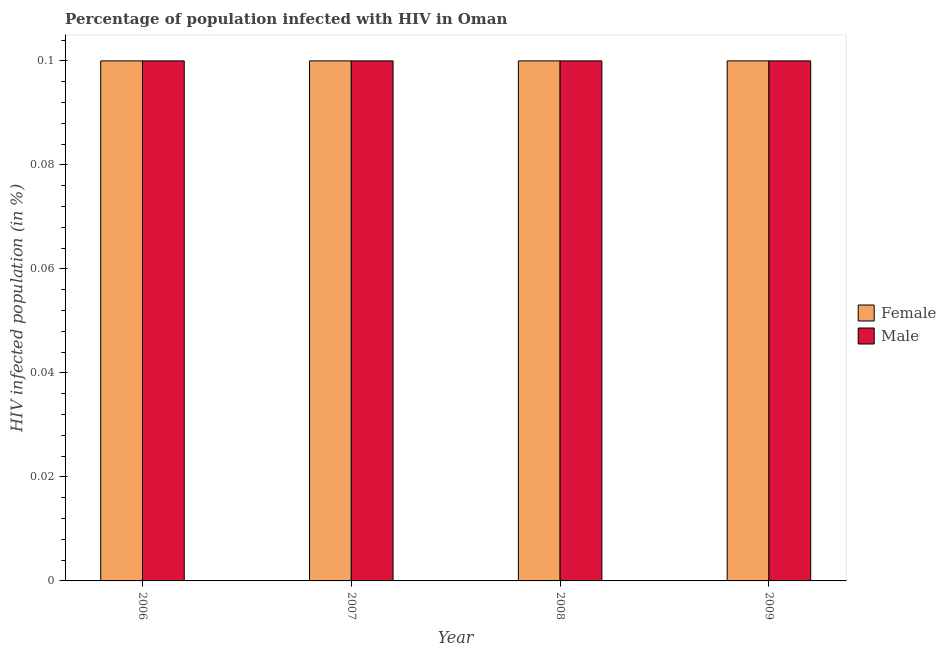How many different coloured bars are there?
Make the answer very short. 2. How many groups of bars are there?
Keep it short and to the point. 4. Are the number of bars on each tick of the X-axis equal?
Give a very brief answer. Yes. How many bars are there on the 1st tick from the right?
Your response must be concise. 2. What is the label of the 3rd group of bars from the left?
Your answer should be very brief. 2008. Across all years, what is the maximum percentage of females who are infected with hiv?
Provide a succinct answer. 0.1. Across all years, what is the minimum percentage of females who are infected with hiv?
Provide a succinct answer. 0.1. In which year was the percentage of females who are infected with hiv maximum?
Your answer should be very brief. 2006. In which year was the percentage of females who are infected with hiv minimum?
Keep it short and to the point. 2006. In how many years, is the percentage of males who are infected with hiv greater than 0.088 %?
Your response must be concise. 4. What is the ratio of the percentage of females who are infected with hiv in 2006 to that in 2007?
Give a very brief answer. 1. What is the difference between the highest and the second highest percentage of males who are infected with hiv?
Provide a short and direct response. 0. In how many years, is the percentage of males who are infected with hiv greater than the average percentage of males who are infected with hiv taken over all years?
Provide a short and direct response. 0. What does the 2nd bar from the right in 2008 represents?
Ensure brevity in your answer.  Female. Are all the bars in the graph horizontal?
Keep it short and to the point. No. What is the difference between two consecutive major ticks on the Y-axis?
Your answer should be very brief. 0.02. Does the graph contain any zero values?
Provide a short and direct response. No. How many legend labels are there?
Make the answer very short. 2. How are the legend labels stacked?
Offer a terse response. Vertical. What is the title of the graph?
Offer a very short reply. Percentage of population infected with HIV in Oman. Does "Largest city" appear as one of the legend labels in the graph?
Keep it short and to the point. No. What is the label or title of the Y-axis?
Make the answer very short. HIV infected population (in %). What is the HIV infected population (in %) in Female in 2006?
Your response must be concise. 0.1. What is the HIV infected population (in %) in Female in 2008?
Ensure brevity in your answer.  0.1. Across all years, what is the maximum HIV infected population (in %) in Male?
Your answer should be compact. 0.1. Across all years, what is the minimum HIV infected population (in %) of Female?
Provide a succinct answer. 0.1. What is the total HIV infected population (in %) in Male in the graph?
Your response must be concise. 0.4. What is the difference between the HIV infected population (in %) in Female in 2006 and that in 2008?
Your answer should be very brief. 0. What is the difference between the HIV infected population (in %) in Male in 2006 and that in 2008?
Give a very brief answer. 0. What is the difference between the HIV infected population (in %) in Female in 2006 and that in 2009?
Your answer should be compact. 0. What is the difference between the HIV infected population (in %) of Female in 2007 and that in 2009?
Your answer should be compact. 0. What is the difference between the HIV infected population (in %) in Male in 2007 and that in 2009?
Your response must be concise. 0. What is the difference between the HIV infected population (in %) of Male in 2008 and that in 2009?
Your answer should be compact. 0. What is the difference between the HIV infected population (in %) in Female in 2006 and the HIV infected population (in %) in Male in 2007?
Make the answer very short. 0. What is the difference between the HIV infected population (in %) of Female in 2006 and the HIV infected population (in %) of Male in 2008?
Offer a very short reply. 0. What is the difference between the HIV infected population (in %) of Female in 2008 and the HIV infected population (in %) of Male in 2009?
Provide a succinct answer. 0. What is the average HIV infected population (in %) in Male per year?
Keep it short and to the point. 0.1. In the year 2006, what is the difference between the HIV infected population (in %) in Female and HIV infected population (in %) in Male?
Keep it short and to the point. 0. In the year 2007, what is the difference between the HIV infected population (in %) in Female and HIV infected population (in %) in Male?
Offer a terse response. 0. What is the ratio of the HIV infected population (in %) in Male in 2006 to that in 2007?
Offer a very short reply. 1. What is the ratio of the HIV infected population (in %) in Male in 2006 to that in 2008?
Your answer should be very brief. 1. What is the ratio of the HIV infected population (in %) in Male in 2006 to that in 2009?
Offer a very short reply. 1. What is the ratio of the HIV infected population (in %) in Male in 2007 to that in 2009?
Offer a terse response. 1. What is the ratio of the HIV infected population (in %) of Female in 2008 to that in 2009?
Provide a short and direct response. 1. What is the difference between the highest and the second highest HIV infected population (in %) of Male?
Offer a terse response. 0. What is the difference between the highest and the lowest HIV infected population (in %) of Male?
Provide a short and direct response. 0. 